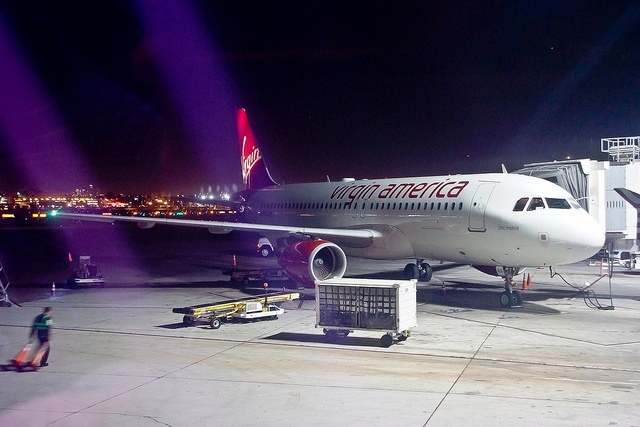Describe the objects in this image and their specific colors. I can see airplane in black, gray, white, darkgray, and purple tones and people in black, gray, and navy tones in this image. 